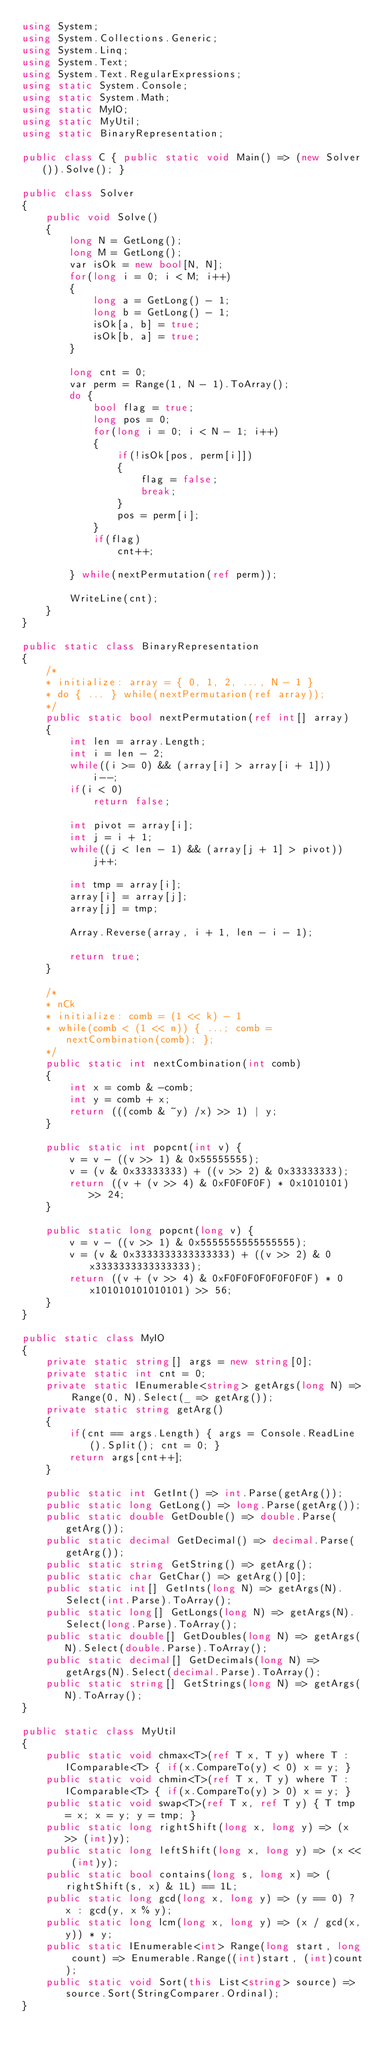Convert code to text. <code><loc_0><loc_0><loc_500><loc_500><_C#_>using System;
using System.Collections.Generic;
using System.Linq;
using System.Text;
using System.Text.RegularExpressions;
using static System.Console;
using static System.Math;
using static MyIO;
using static MyUtil;
using static BinaryRepresentation;

public class C { public static void Main() => (new Solver()).Solve(); }

public class Solver
{
	public void Solve()
	{
		long N = GetLong();
		long M = GetLong();
		var isOk = new bool[N, N];
		for(long i = 0; i < M; i++)
		{
			long a = GetLong() - 1;
			long b = GetLong() - 1;
			isOk[a, b] = true;
			isOk[b, a] = true;
		}

		long cnt = 0;
		var perm = Range(1, N - 1).ToArray();
		do {
			bool flag = true;
			long pos = 0;
			for(long i = 0; i < N - 1; i++)
			{
				if(!isOk[pos, perm[i]])
				{
					flag = false;
					break;
				}
				pos = perm[i];
			}
			if(flag)
				cnt++;

		} while(nextPermutation(ref perm));

		WriteLine(cnt);
	}
}

public static class BinaryRepresentation
{
	/*
	* initialize: array = { 0, 1, 2, ..., N - 1 } 
	* do { ... } while(nextPermutarion(ref array));
	*/
	public static bool nextPermutation(ref int[] array)
	{
		int len = array.Length;
		int i = len - 2;
		while((i >= 0) && (array[i] > array[i + 1]))
			i--;
		if(i < 0)
			return false;

		int pivot = array[i];
		int j = i + 1;
		while((j < len - 1) && (array[j + 1] > pivot))
			j++;
		
		int tmp = array[i];
		array[i] = array[j];
		array[j] = tmp;
		
		Array.Reverse(array, i + 1, len - i - 1);

		return true;
	}

	/* 
	* nCk
	* initialize: comb = (1 << k) - 1
	* while(comb < (1 << n)) { ...; comb = nextCombination(comb); };
	*/
	public static int nextCombination(int comb)
	{
		int x = comb & -comb;
		int y = comb + x;
		return (((comb & ~y) /x) >> 1) | y;
	}

	public static int popcnt(int v) {
		v = v - ((v >> 1) & 0x55555555);
		v = (v & 0x33333333) + ((v >> 2) & 0x33333333);
		return ((v + (v >> 4) & 0xF0F0F0F) * 0x1010101) >> 24;
	}

	public static long popcnt(long v) {
		v = v - ((v >> 1) & 0x5555555555555555);
		v = (v & 0x3333333333333333) + ((v >> 2) & 0x3333333333333333);
		return ((v + (v >> 4) & 0xF0F0F0F0F0F0F0F) * 0x101010101010101) >> 56;
	}
}

public static class MyIO
{
	private static string[] args = new string[0];
	private static int cnt = 0;
	private static IEnumerable<string> getArgs(long N) => Range(0, N).Select(_ => getArg());
	private static string getArg()
	{
		if(cnt == args.Length) { args = Console.ReadLine().Split(); cnt = 0; }
		return args[cnt++];
	}

	public static int GetInt() => int.Parse(getArg());
	public static long GetLong() => long.Parse(getArg());
	public static double GetDouble() => double.Parse(getArg());
	public static decimal GetDecimal() => decimal.Parse(getArg());
	public static string GetString() => getArg();
	public static char GetChar() => getArg()[0];
	public static int[] GetInts(long N) => getArgs(N).Select(int.Parse).ToArray();
	public static long[] GetLongs(long N) => getArgs(N).Select(long.Parse).ToArray();
	public static double[] GetDoubles(long N) => getArgs(N).Select(double.Parse).ToArray();
	public static decimal[] GetDecimals(long N) => getArgs(N).Select(decimal.Parse).ToArray();
	public static string[] GetStrings(long N) => getArgs(N).ToArray();
}

public static class MyUtil
{
	public static void chmax<T>(ref T x, T y) where T : IComparable<T> { if(x.CompareTo(y) < 0) x = y; }
	public static void chmin<T>(ref T x, T y) where T : IComparable<T> { if(x.CompareTo(y) > 0)	x = y; }
	public static void swap<T>(ref T x, ref T y) { T tmp = x; x = y; y = tmp; }
	public static long rightShift(long x, long y) => (x >> (int)y);
	public static long leftShift(long x, long y) => (x << (int)y);
	public static bool contains(long s, long x) => (rightShift(s, x) & 1L) == 1L;
	public static long gcd(long x, long y) => (y == 0) ? x : gcd(y, x % y);
	public static long lcm(long x, long y) => (x / gcd(x,y)) * y;	
	public static IEnumerable<int> Range(long start, long count) => Enumerable.Range((int)start, (int)count);
	public static void Sort(this List<string> source) => source.Sort(StringComparer.Ordinal);
}
</code> 